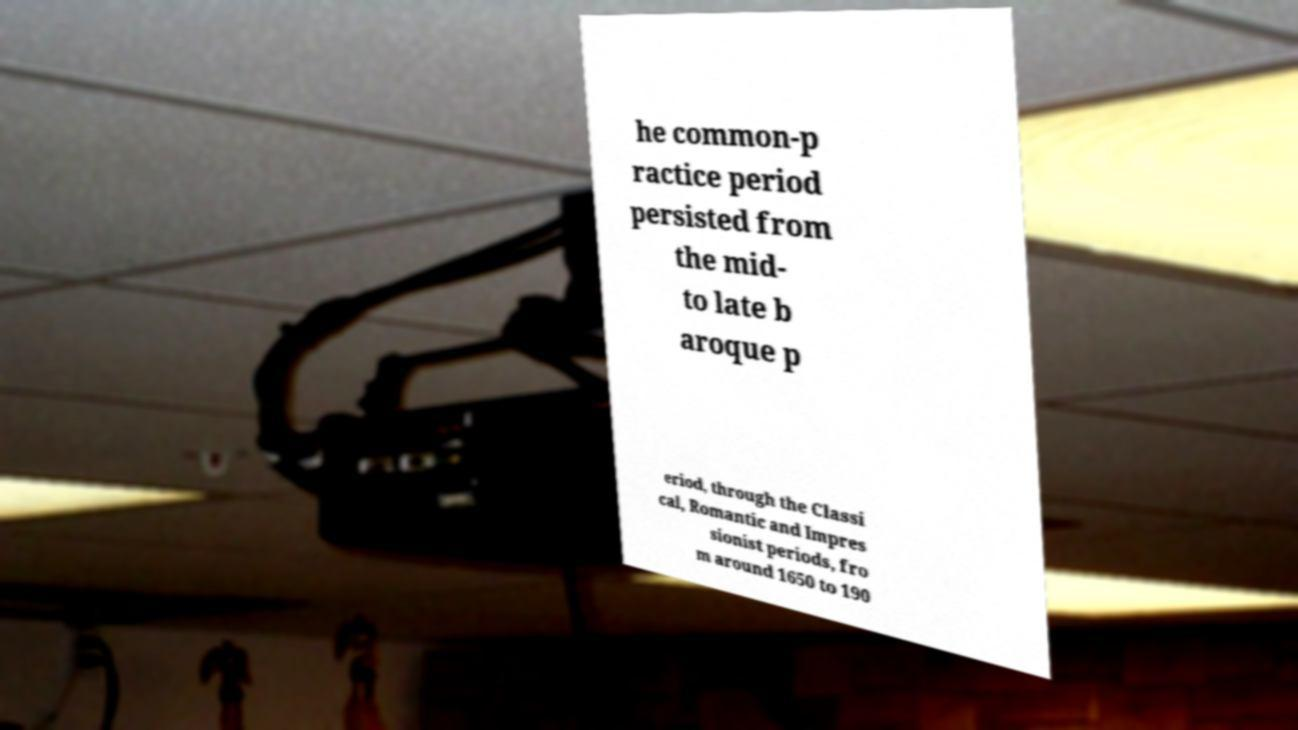I need the written content from this picture converted into text. Can you do that? he common-p ractice period persisted from the mid- to late b aroque p eriod, through the Classi cal, Romantic and Impres sionist periods, fro m around 1650 to 190 